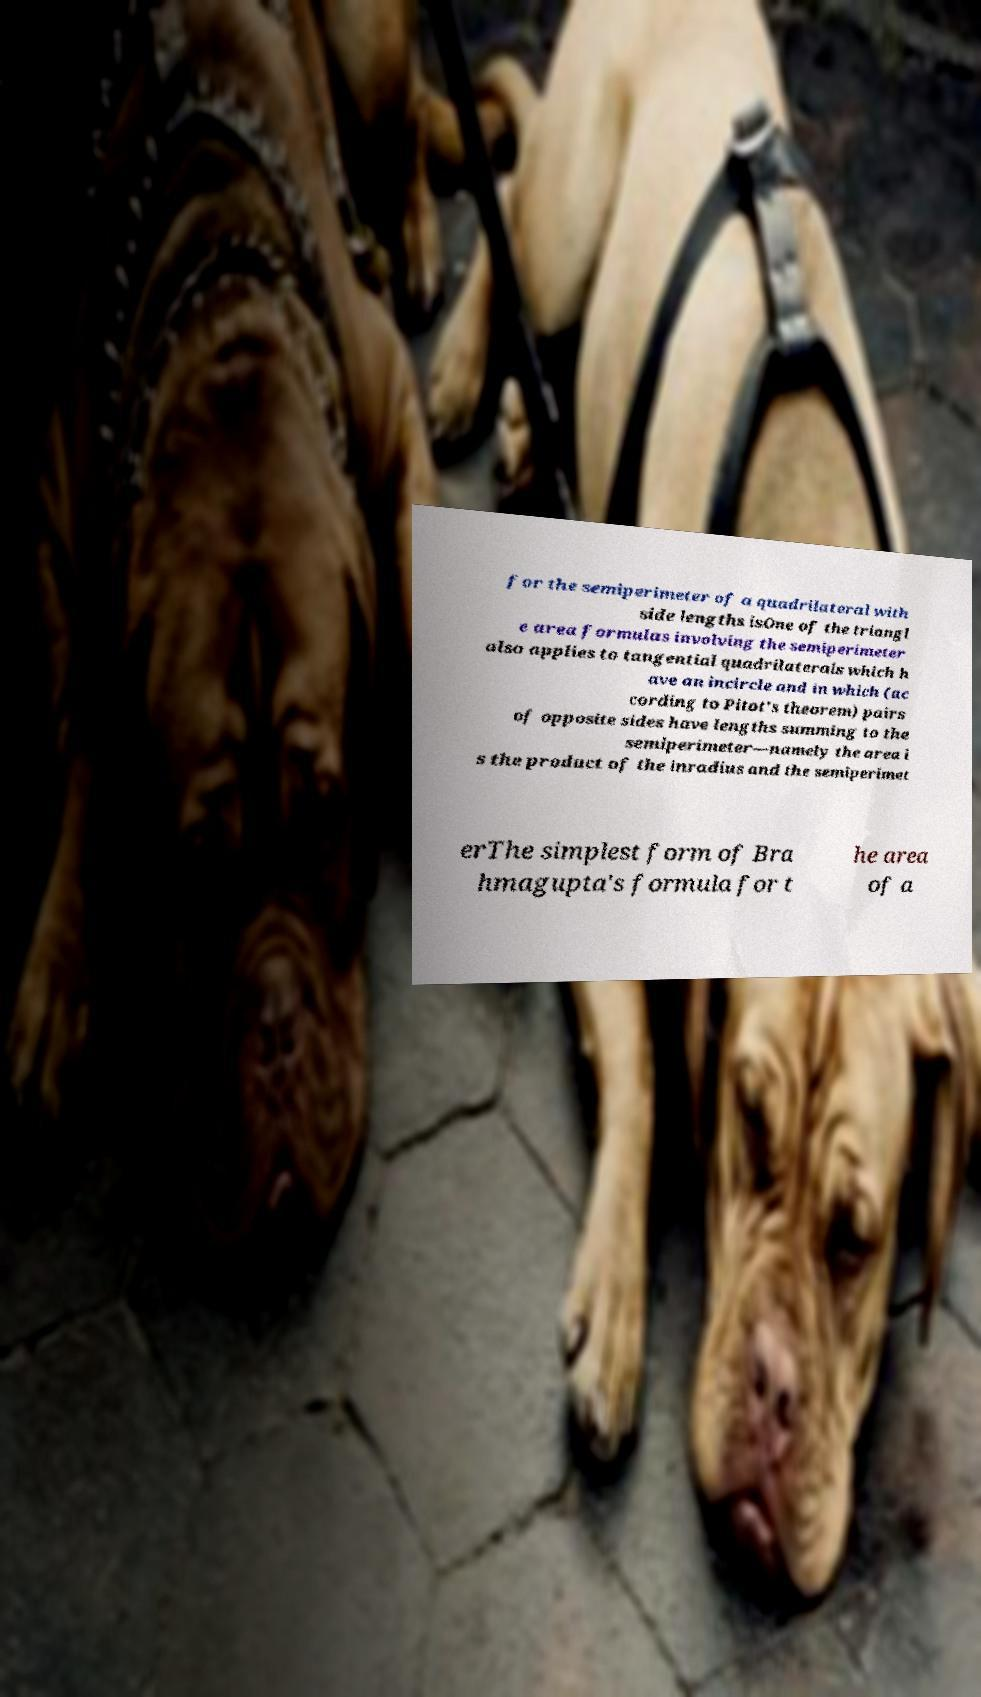There's text embedded in this image that I need extracted. Can you transcribe it verbatim? for the semiperimeter of a quadrilateral with side lengths isOne of the triangl e area formulas involving the semiperimeter also applies to tangential quadrilaterals which h ave an incircle and in which (ac cording to Pitot's theorem) pairs of opposite sides have lengths summing to the semiperimeter—namely the area i s the product of the inradius and the semiperimet erThe simplest form of Bra hmagupta's formula for t he area of a 